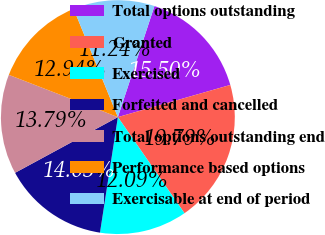<chart> <loc_0><loc_0><loc_500><loc_500><pie_chart><fcel>Total options outstanding<fcel>Granted<fcel>Exercised<fcel>Forfeited and cancelled<fcel>Total options outstanding end<fcel>Performance based options<fcel>Exercisable at end of period<nl><fcel>15.5%<fcel>19.79%<fcel>12.09%<fcel>14.65%<fcel>13.79%<fcel>12.94%<fcel>11.24%<nl></chart> 